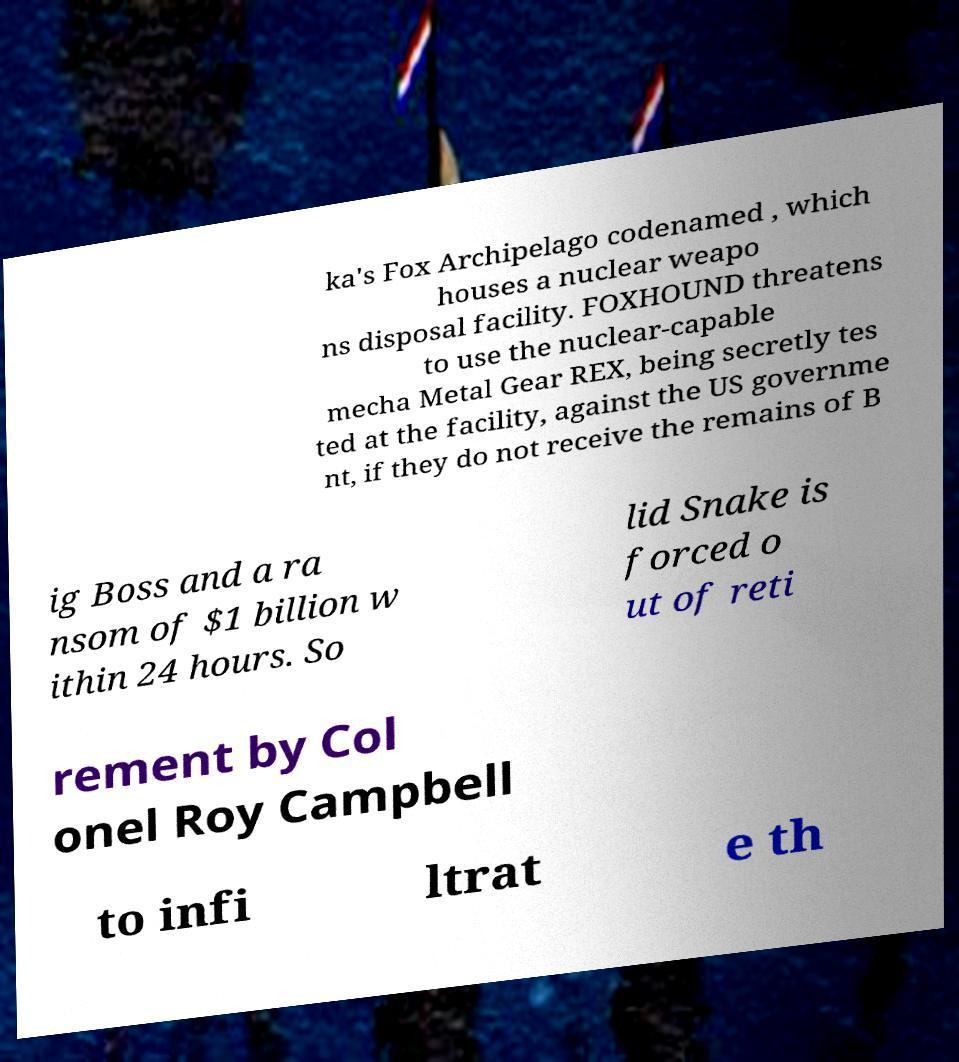I need the written content from this picture converted into text. Can you do that? ka's Fox Archipelago codenamed , which houses a nuclear weapo ns disposal facility. FOXHOUND threatens to use the nuclear-capable mecha Metal Gear REX, being secretly tes ted at the facility, against the US governme nt, if they do not receive the remains of B ig Boss and a ra nsom of $1 billion w ithin 24 hours. So lid Snake is forced o ut of reti rement by Col onel Roy Campbell to infi ltrat e th 